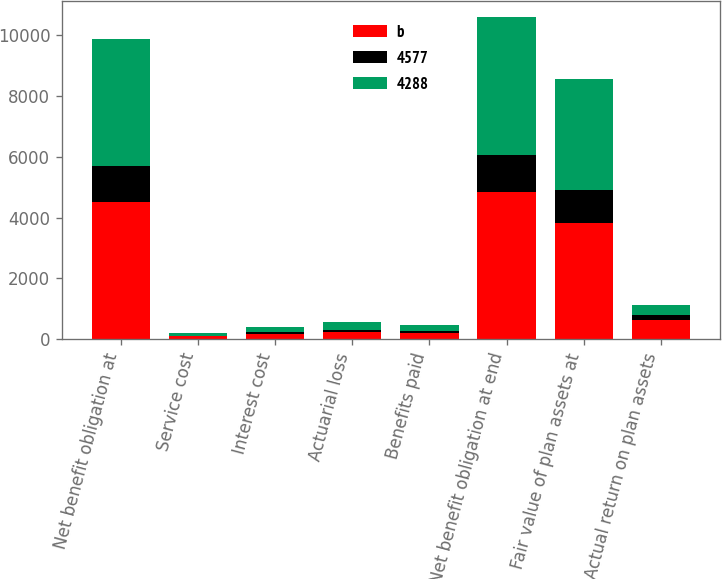Convert chart to OTSL. <chart><loc_0><loc_0><loc_500><loc_500><stacked_bar_chart><ecel><fcel>Net benefit obligation at<fcel>Service cost<fcel>Interest cost<fcel>Actuarial loss<fcel>Benefits paid<fcel>Net benefit obligation at end<fcel>Fair value of plan assets at<fcel>Actual return on plan assets<nl><fcel>b<fcel>4518<fcel>93<fcel>179<fcel>255<fcel>218<fcel>4827<fcel>3813<fcel>634<nl><fcel>4577<fcel>1170<fcel>21<fcel>47<fcel>53<fcel>59<fcel>1240<fcel>1101<fcel>171<nl><fcel>4288<fcel>4197<fcel>81<fcel>185<fcel>265<fcel>210<fcel>4518<fcel>3653<fcel>313<nl></chart> 